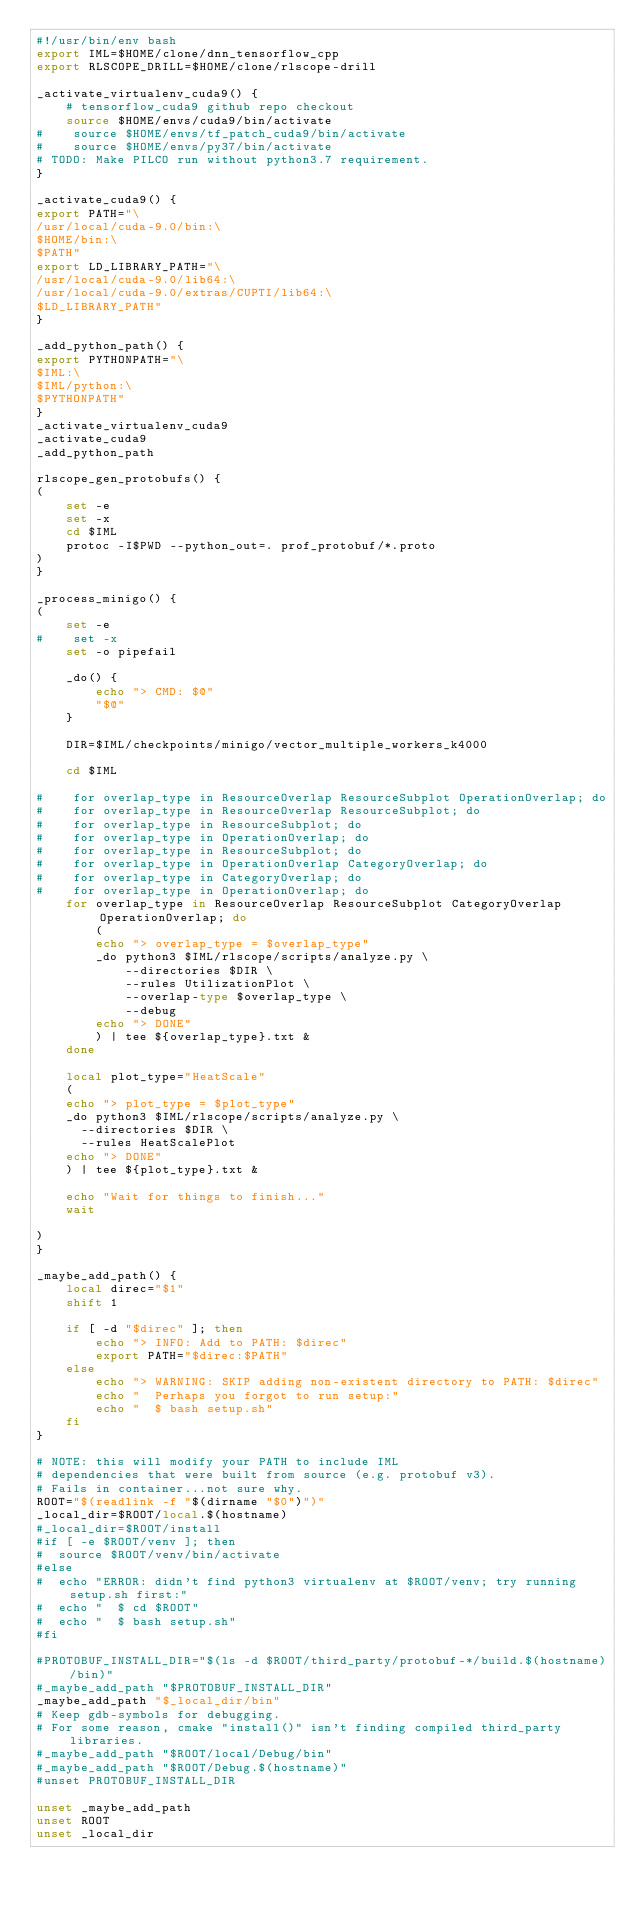<code> <loc_0><loc_0><loc_500><loc_500><_Bash_>#!/usr/bin/env bash
export IML=$HOME/clone/dnn_tensorflow_cpp
export RLSCOPE_DRILL=$HOME/clone/rlscope-drill

_activate_virtualenv_cuda9() {
    # tensorflow_cuda9 github repo checkout
    source $HOME/envs/cuda9/bin/activate
#    source $HOME/envs/tf_patch_cuda9/bin/activate
#    source $HOME/envs/py37/bin/activate
# TODO: Make PILCO run without python3.7 requirement.
}

_activate_cuda9() {
export PATH="\
/usr/local/cuda-9.0/bin:\
$HOME/bin:\
$PATH"
export LD_LIBRARY_PATH="\
/usr/local/cuda-9.0/lib64:\
/usr/local/cuda-9.0/extras/CUPTI/lib64:\
$LD_LIBRARY_PATH"
}

_add_python_path() {
export PYTHONPATH="\
$IML:\
$IML/python:\
$PYTHONPATH"
}
_activate_virtualenv_cuda9
_activate_cuda9
_add_python_path

rlscope_gen_protobufs() {
(
    set -e
    set -x
    cd $IML
    protoc -I$PWD --python_out=. prof_protobuf/*.proto
)
}

_process_minigo() {
(
    set -e
#    set -x
    set -o pipefail

    _do() {
        echo "> CMD: $@"
        "$@"
    }

    DIR=$IML/checkpoints/minigo/vector_multiple_workers_k4000

    cd $IML

#    for overlap_type in ResourceOverlap ResourceSubplot OperationOverlap; do
#    for overlap_type in ResourceOverlap ResourceSubplot; do
#    for overlap_type in ResourceSubplot; do
#    for overlap_type in OperationOverlap; do
#    for overlap_type in ResourceSubplot; do
#    for overlap_type in OperationOverlap CategoryOverlap; do
#    for overlap_type in CategoryOverlap; do
#    for overlap_type in OperationOverlap; do
    for overlap_type in ResourceOverlap ResourceSubplot CategoryOverlap OperationOverlap; do
        (
        echo "> overlap_type = $overlap_type"
        _do python3 $IML/rlscope/scripts/analyze.py \
            --directories $DIR \
            --rules UtilizationPlot \
            --overlap-type $overlap_type \
            --debug
        echo "> DONE"
        ) | tee ${overlap_type}.txt &
    done

    local plot_type="HeatScale"
    (
    echo "> plot_type = $plot_type"
    _do python3 $IML/rlscope/scripts/analyze.py \
      --directories $DIR \
      --rules HeatScalePlot
    echo "> DONE"
    ) | tee ${plot_type}.txt &

    echo "Wait for things to finish..."
    wait

)
}

_maybe_add_path() {
    local direc="$1"
    shift 1

    if [ -d "$direc" ]; then
        echo "> INFO: Add to PATH: $direc"
        export PATH="$direc:$PATH"
    else
        echo "> WARNING: SKIP adding non-existent directory to PATH: $direc"
        echo "  Perhaps you forgot to run setup:"
        echo "  $ bash setup.sh"
    fi
}

# NOTE: this will modify your PATH to include IML
# dependencies that were built from source (e.g. protobuf v3).
# Fails in container...not sure why.
ROOT="$(readlink -f "$(dirname "$0")")"
_local_dir=$ROOT/local.$(hostname)
#_local_dir=$ROOT/install
#if [ -e $ROOT/venv ]; then
#  source $ROOT/venv/bin/activate
#else
#  echo "ERROR: didn't find python3 virtualenv at $ROOT/venv; try running setup.sh first:"
#  echo "  $ cd $ROOT"
#  echo "  $ bash setup.sh"
#fi

#PROTOBUF_INSTALL_DIR="$(ls -d $ROOT/third_party/protobuf-*/build.$(hostname)/bin)"
#_maybe_add_path "$PROTOBUF_INSTALL_DIR"
_maybe_add_path "$_local_dir/bin"
# Keep gdb-symbols for debugging.
# For some reason, cmake "install()" isn't finding compiled third_party libraries.
#_maybe_add_path "$ROOT/local/Debug/bin"
#_maybe_add_path "$ROOT/Debug.$(hostname)"
#unset PROTOBUF_INSTALL_DIR

unset _maybe_add_path
unset ROOT
unset _local_dir
</code> 